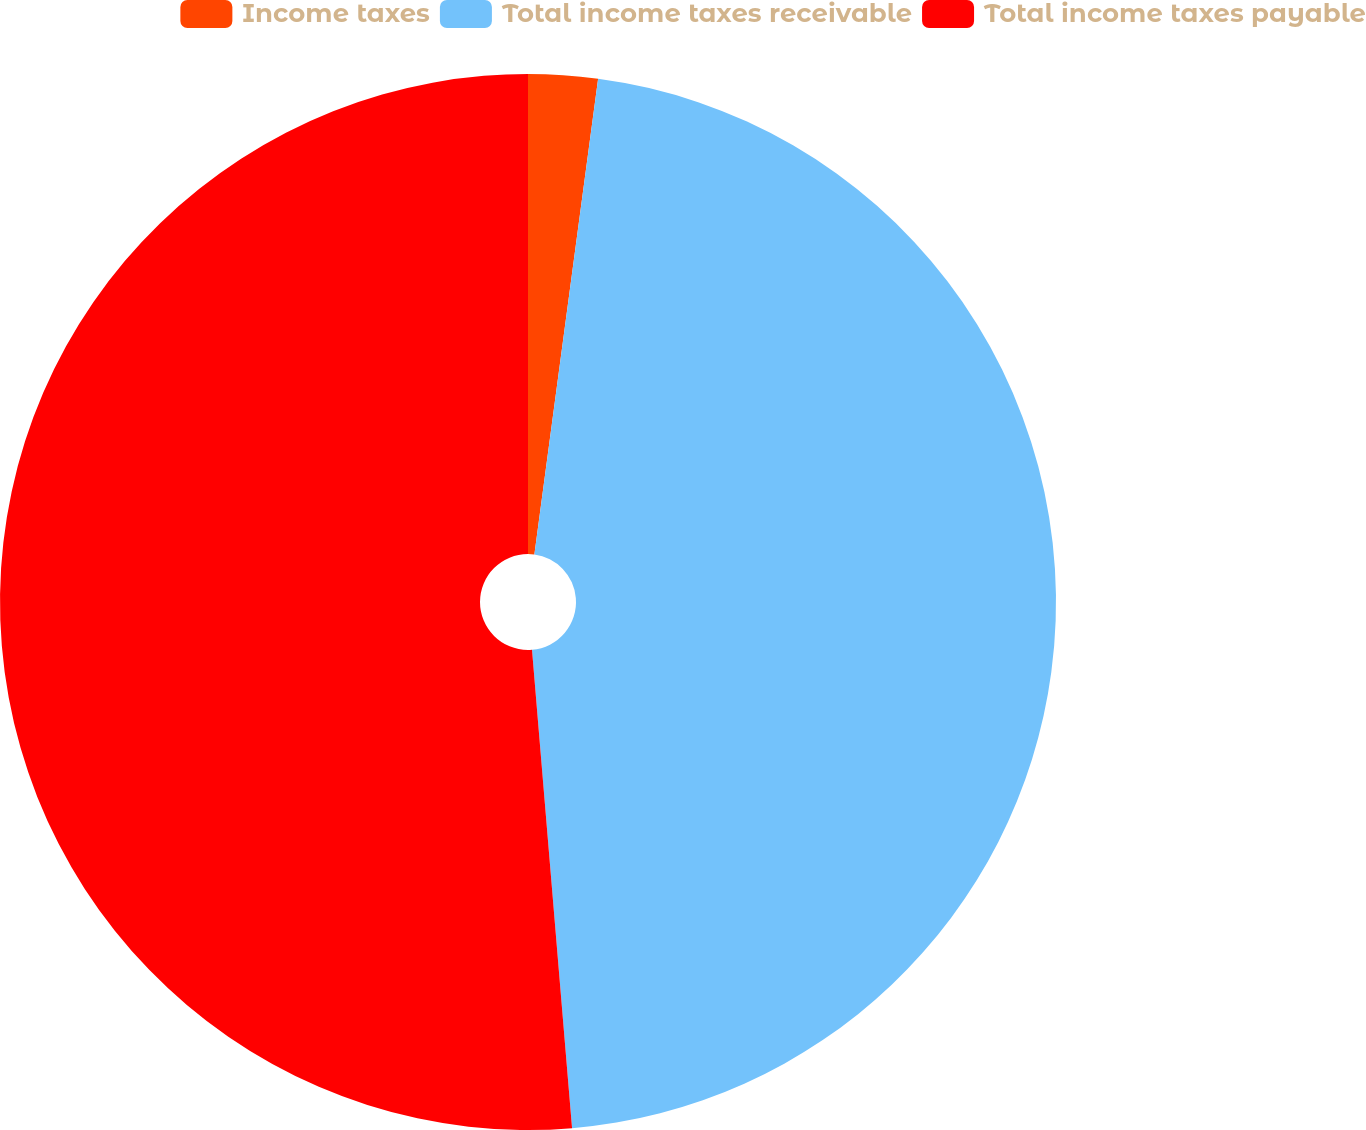Convert chart. <chart><loc_0><loc_0><loc_500><loc_500><pie_chart><fcel>Income taxes<fcel>Total income taxes receivable<fcel>Total income taxes payable<nl><fcel>2.12%<fcel>46.55%<fcel>51.33%<nl></chart> 